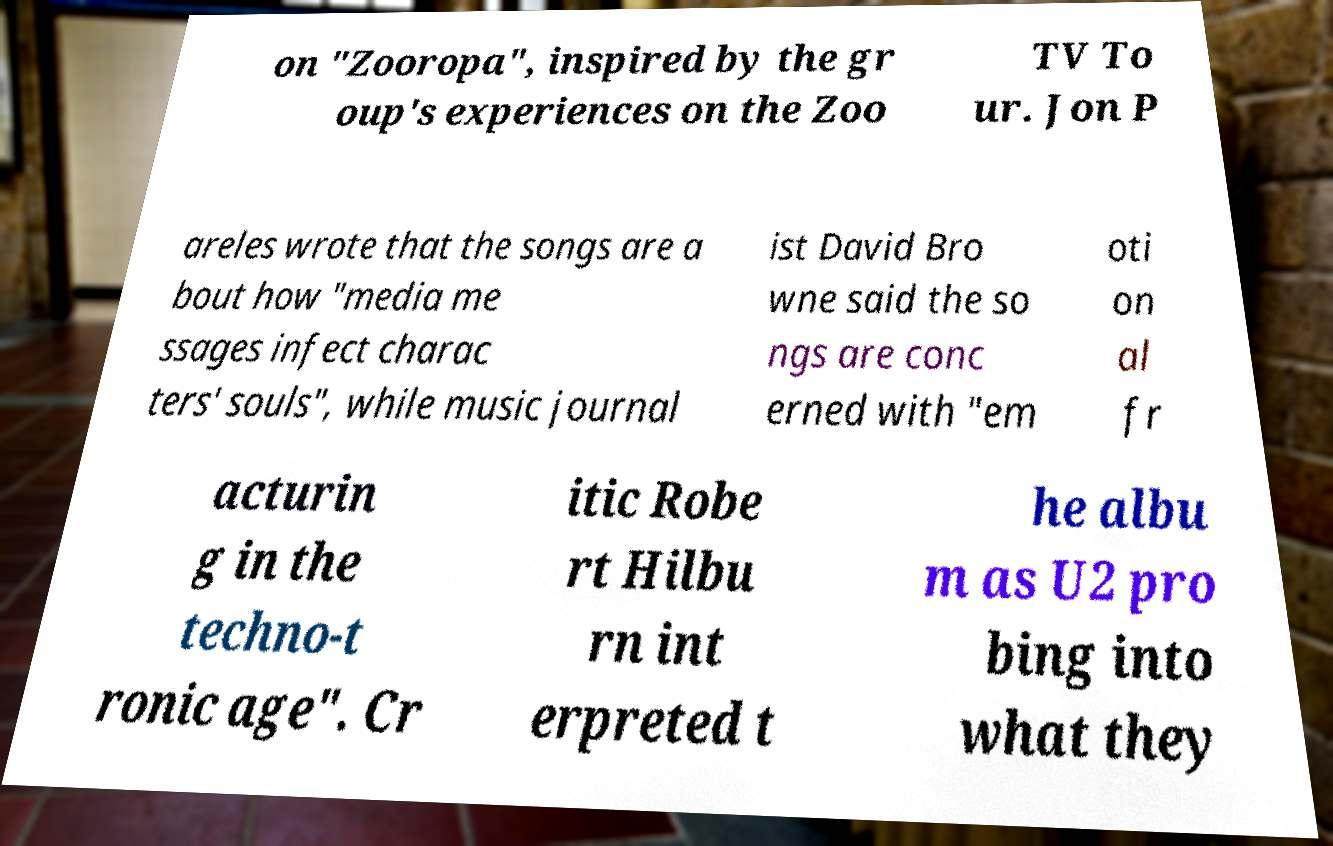Could you extract and type out the text from this image? on "Zooropa", inspired by the gr oup's experiences on the Zoo TV To ur. Jon P areles wrote that the songs are a bout how "media me ssages infect charac ters' souls", while music journal ist David Bro wne said the so ngs are conc erned with "em oti on al fr acturin g in the techno-t ronic age". Cr itic Robe rt Hilbu rn int erpreted t he albu m as U2 pro bing into what they 